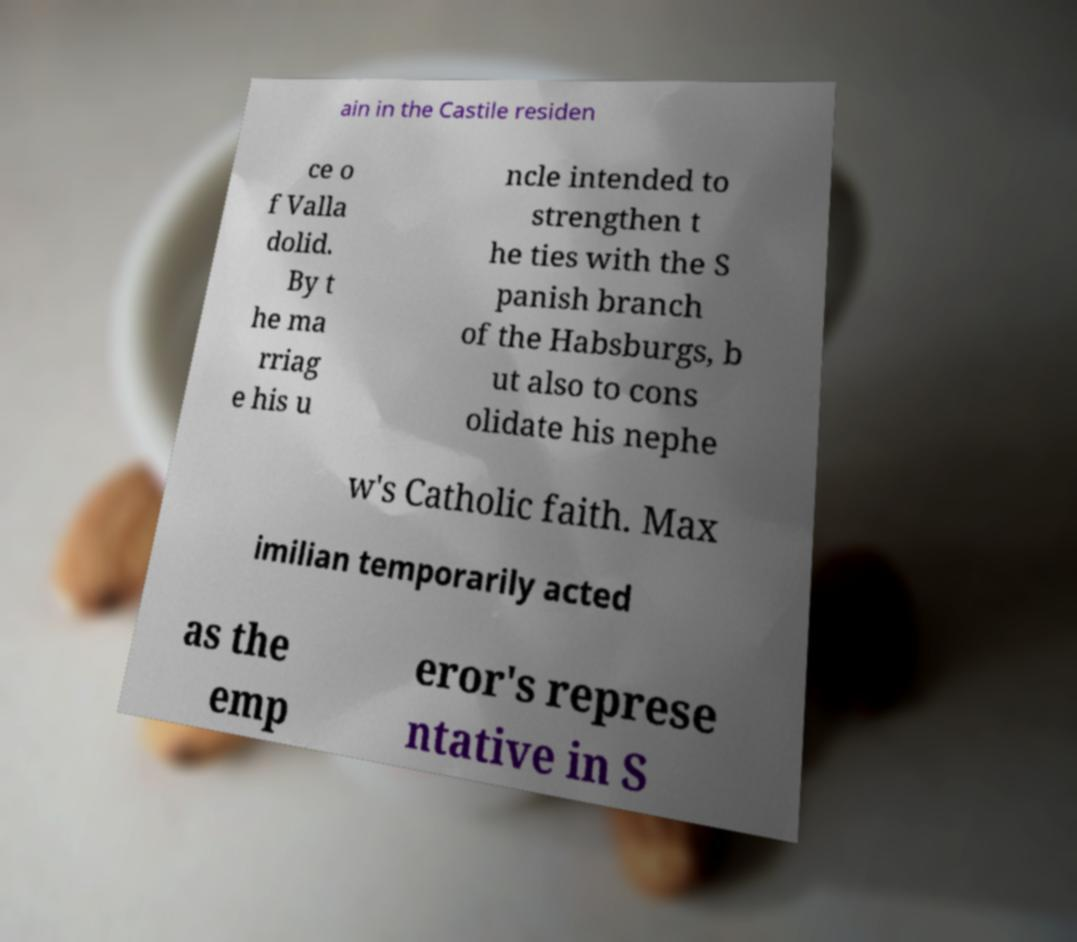Can you accurately transcribe the text from the provided image for me? ain in the Castile residen ce o f Valla dolid. By t he ma rriag e his u ncle intended to strengthen t he ties with the S panish branch of the Habsburgs, b ut also to cons olidate his nephe w's Catholic faith. Max imilian temporarily acted as the emp eror's represe ntative in S 